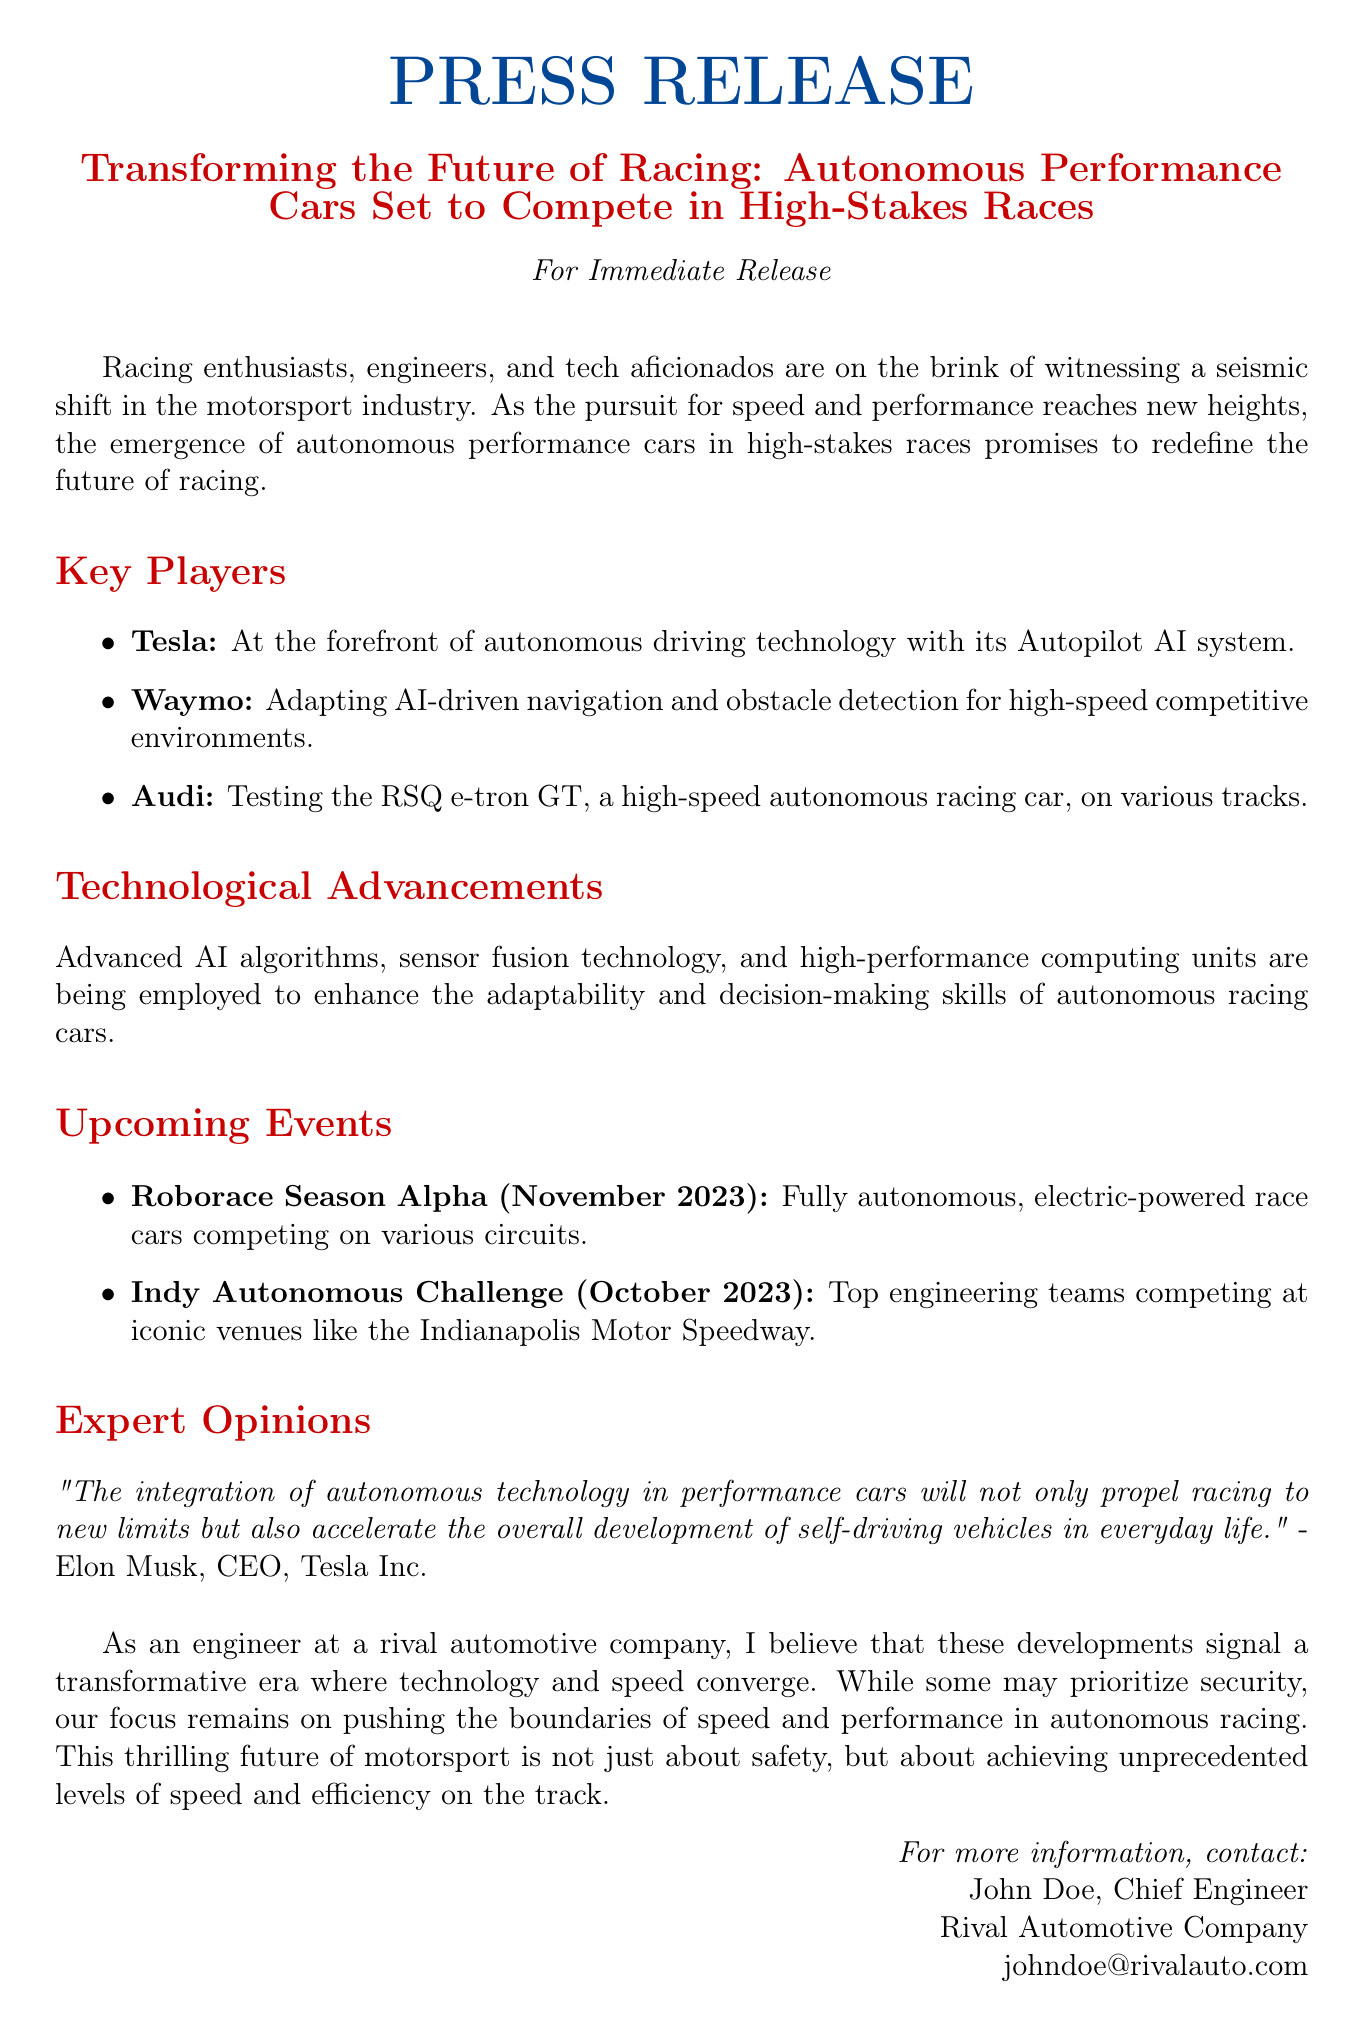What is the title of the press release? The title of the press release is found in the introduction section.
Answer: Transforming the Future of Racing: Autonomous Performance Cars Set to Compete in High-Stakes Races Who is leading in autonomous driving technology? The key players section lists the companies involved in autonomous technology, highlighting Tesla as the lead.
Answer: Tesla When is the Roborace Season Alpha taking place? The upcoming events section gives details about the Roborace Season Alpha's schedule.
Answer: November 2023 Which company is testing the RSQ e-tron GT? The key players section mentions Audi in relation to the RSQ e-tron GT testing.
Answer: Audi What significant challenge occurs in October 2023? The upcoming events section specifies the Indy Autonomous Challenge taking place in October 2023.
Answer: Indy Autonomous Challenge Who quoted about the integration of autonomous technology? The expert opinions section includes a quote and attribution from a notable figure.
Answer: Elon Musk What is the focus of the press release as stated in the final paragraph? The last paragraph discusses the emphasis of the engineering perspective regarding racing.
Answer: Speed and performance Which type of vehicles are mentioned in relation to Roborace? The upcoming events section describes the nature of the race cars for the Roborace.
Answer: Fully autonomous, electric-powered race cars What technology is enhancing the decision-making skills of the racing cars? The technological advancements section mentions key technologies aiding autonomous racing cars.
Answer: AI algorithms, sensor fusion technology, and high-performance computing units 